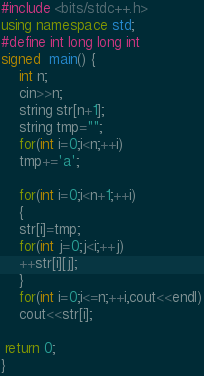<code> <loc_0><loc_0><loc_500><loc_500><_C++_>#include <bits/stdc++.h>
using namespace std;
#define int long long int
signed  main() {
    int n;
    cin>>n;
    string str[n+1];
    string tmp="";
    for(int i=0;i<n;++i)
    tmp+='a';
    
    for(int i=0;i<n+1;++i)
    {
    str[i]=tmp;
    for(int j=0;j<i;++j)
    ++str[i][j];
    }
    for(int i=0;i<=n;++i,cout<<endl)
    cout<<str[i];
    
 return 0;   
}
</code> 